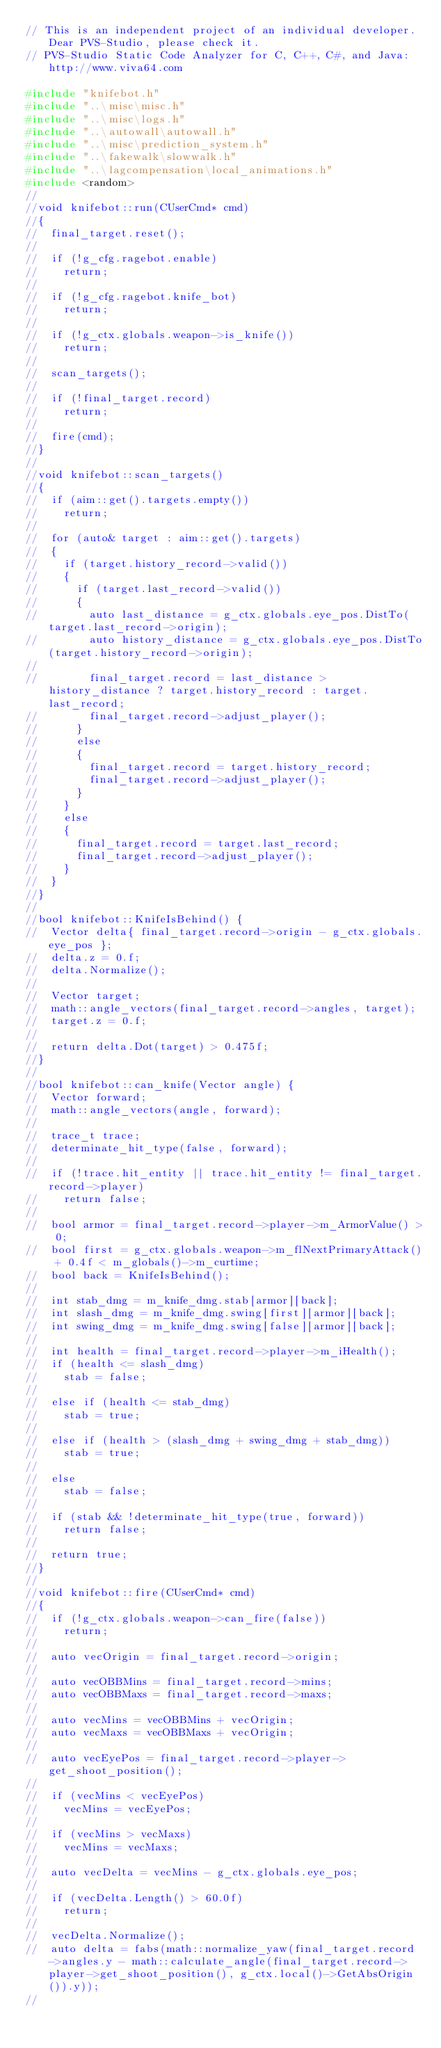Convert code to text. <code><loc_0><loc_0><loc_500><loc_500><_C++_>// This is an independent project of an individual developer. Dear PVS-Studio, please check it.
// PVS-Studio Static Code Analyzer for C, C++, C#, and Java: http://www.viva64.com

#include "knifebot.h"
#include "..\misc\misc.h"
#include "..\misc\logs.h"
#include "..\autowall\autowall.h"
#include "..\misc\prediction_system.h"
#include "..\fakewalk\slowwalk.h"
#include "..\lagcompensation\local_animations.h"
#include <random>
//
//void knifebot::run(CUserCmd* cmd)
//{
//	final_target.reset();
//
//	if (!g_cfg.ragebot.enable)
//		return;
//
//	if (!g_cfg.ragebot.knife_bot)
//		return;
//
//	if (!g_ctx.globals.weapon->is_knife())
//		return;
//
//	scan_targets();
//
//	if (!final_target.record)
//		return;
//
//	fire(cmd);
//}
//
//void knifebot::scan_targets()
//{
//	if (aim::get().targets.empty())
//		return;
//
//	for (auto& target : aim::get().targets)
//	{
//		if (target.history_record->valid())
//		{
//			if (target.last_record->valid())
//			{
//				auto last_distance = g_ctx.globals.eye_pos.DistTo(target.last_record->origin);
//				auto history_distance = g_ctx.globals.eye_pos.DistTo(target.history_record->origin);
//
//				final_target.record = last_distance > history_distance ? target.history_record : target.last_record;
//				final_target.record->adjust_player();
//			}
//			else
//			{
//				final_target.record = target.history_record;
//				final_target.record->adjust_player();
//			}
//		}
//		else
//		{
//			final_target.record = target.last_record;
//			final_target.record->adjust_player();
//		}
//	}
//}
//
//bool knifebot::KnifeIsBehind() {
//	Vector delta{ final_target.record->origin - g_ctx.globals.eye_pos };
//	delta.z = 0.f;
//	delta.Normalize();
//
//	Vector target;
//	math::angle_vectors(final_target.record->angles, target);
//	target.z = 0.f;
//
//	return delta.Dot(target) > 0.475f;
//}
//
//bool knifebot::can_knife(Vector angle) {
//	Vector forward;
//	math::angle_vectors(angle, forward);
//
//	trace_t trace;
//	determinate_hit_type(false, forward);
//
//	if (!trace.hit_entity || trace.hit_entity != final_target.record->player)
//		return false;
//
//	bool armor = final_target.record->player->m_ArmorValue() > 0;
//	bool first = g_ctx.globals.weapon->m_flNextPrimaryAttack() + 0.4f < m_globals()->m_curtime;
//	bool back = KnifeIsBehind();
//
//	int stab_dmg = m_knife_dmg.stab[armor][back];
//	int slash_dmg = m_knife_dmg.swing[first][armor][back];
//	int swing_dmg = m_knife_dmg.swing[false][armor][back];
//
//	int health = final_target.record->player->m_iHealth();
//	if (health <= slash_dmg)
//		stab = false;
//
//	else if (health <= stab_dmg)
//		stab = true;
//
//	else if (health > (slash_dmg + swing_dmg + stab_dmg))
//		stab = true;
//
//	else
//		stab = false;
//
//	if (stab && !determinate_hit_type(true, forward))
//		return false;
//
//	return true;
//}
//
//void knifebot::fire(CUserCmd* cmd)
//{
//	if (!g_ctx.globals.weapon->can_fire(false))
//		return;
//
//	auto vecOrigin = final_target.record->origin;
//
//	auto vecOBBMins = final_target.record->mins;
//	auto vecOBBMaxs = final_target.record->maxs;
//
//	auto vecMins = vecOBBMins + vecOrigin;
//	auto vecMaxs = vecOBBMaxs + vecOrigin;
//
//	auto vecEyePos = final_target.record->player->get_shoot_position();
//
//	if (vecMins < vecEyePos)
//		vecMins = vecEyePos;
//
//	if (vecMins > vecMaxs)
//		vecMins = vecMaxs;
//
//	auto vecDelta = vecMins - g_ctx.globals.eye_pos;
//
//	if (vecDelta.Length() > 60.0f)
//		return;
//
//	vecDelta.Normalize();
//	auto delta = fabs(math::normalize_yaw(final_target.record->angles.y - math::calculate_angle(final_target.record->player->get_shoot_position(), g_ctx.local()->GetAbsOrigin()).y));
//</code> 